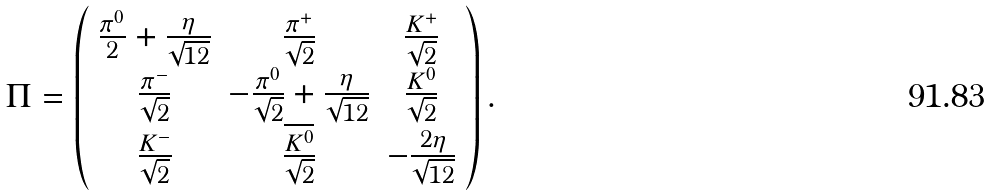<formula> <loc_0><loc_0><loc_500><loc_500>\Pi = \left ( \begin{array} { c c c } \frac { \pi ^ { 0 } } { 2 } + \frac { \eta } { \sqrt { 1 2 } } & \frac { \pi ^ { + } } { \sqrt { 2 } } & \frac { K ^ { + } } { \sqrt { 2 } } \\ \frac { \pi ^ { - } } { \sqrt { 2 } } & - \frac { \pi ^ { 0 } } { \sqrt { 2 } } + \frac { \eta } { \sqrt { 1 2 } } & \frac { K ^ { 0 } } { \sqrt { 2 } } \\ \frac { K ^ { - } } { \sqrt { 2 } } & \frac { \overline { K ^ { 0 } } } { \sqrt { 2 } } & - \frac { 2 \eta } { \sqrt { 1 2 } } \end{array} \right ) .</formula> 